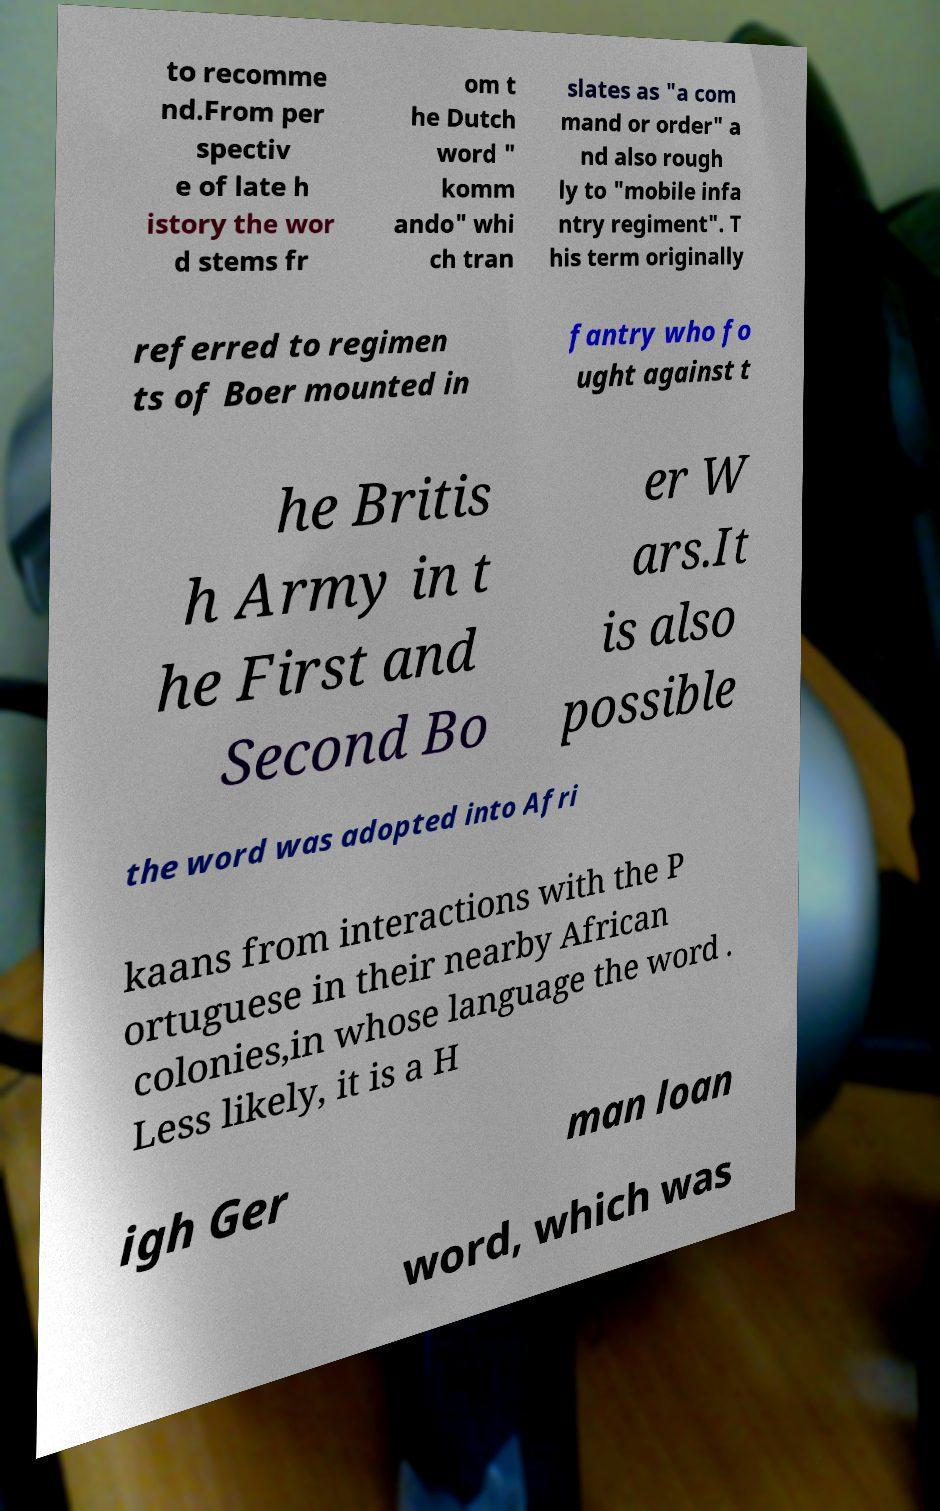Please identify and transcribe the text found in this image. to recomme nd.From per spectiv e of late h istory the wor d stems fr om t he Dutch word " komm ando" whi ch tran slates as "a com mand or order" a nd also rough ly to "mobile infa ntry regiment". T his term originally referred to regimen ts of Boer mounted in fantry who fo ught against t he Britis h Army in t he First and Second Bo er W ars.It is also possible the word was adopted into Afri kaans from interactions with the P ortuguese in their nearby African colonies,in whose language the word . Less likely, it is a H igh Ger man loan word, which was 